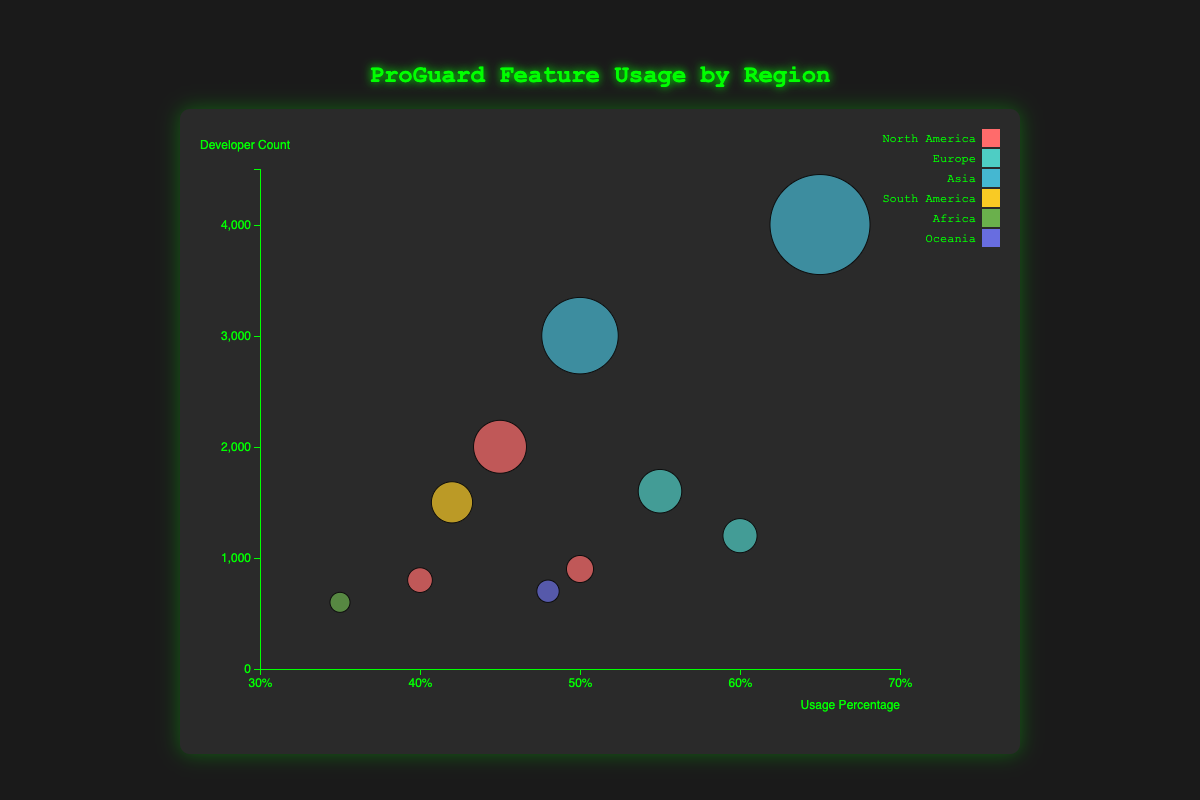What is the title of the chart? The title is displayed at the top of the chart in the larger font size: "ProGuard Feature Usage by Region".
Answer: ProGuard Feature Usage by Region What is the x-axis label? The x-axis label is found at the bottom of the x-axis, indicating the horizontal measurement: "Usage Percentage".
Answer: Usage Percentage What is the largest bubble representing and which data point does it correspond to? The largest bubble represents the highest developer count. It corresponds to China, with 4000 developers and 65% usage percentage for the "Obfuscation" feature.
Answer: China Which region has the highest usage percentage for the "Shrinking" feature, and what is the value? In the figure, bubbles are color-coded by region. The bubble for "Shrinking" with the highest usage percentage is found in the United Kingdom, in the Europe region, with a 60% usage percentage.
Answer: United Kingdom, 60% How many developers from North America use ProGuard's Optimization feature? There are bubbles for North America labeled "USA" and "Mexico" with the "Optimization" feature. Adding the developer counts (2000 for USA and 900 for Mexico) totals 2900 developers.
Answer: 2900 Which country has a higher usage percentage for ProGuard's Optimization feature, India or Nigeria? By comparing the usage percentages for India and Nigeria on the x-axis, India has 50% while Nigeria has 35%. India has a higher usage percentage.
Answer: India What is the difference in developer count between the country with the maximum and minimum usage percentages for the "Obfuscation" feature? The maximum usage percentage for "Obfuscation" is in China (65%) and the minimum is in Australia (48%). The difference in developer count is 4000 - 700 = 3300.
Answer: 3300 Which regions have countries with an average usage percentage above 50%? Calculate the average usage percentage for each region: 
- North America (USA: 45%, Canada: 40%, Mexico: 50%) = (45+40+50)/3 = 45%
- Europe (Germany: 55%, UK: 60%) = (55+60)/2 = 57.5%
- Asia (India: 50%, China: 65%) = (50+65)/2 = 57.5%
- South America (Brazil: 42%) = 42%
- Africa (Nigeria: 35%) = 35%
- Oceania (Australia: 48%) = 48%
Regions with an average above 50% are Europe and Asia.
Answer: Europe and Asia How many bubbles are on the chart? Count the total number of bubbles representing individual data points. There are 10 bubbles.
Answer: 10 Which feature has the highest usage percentage in Asia, and what is the percentage? By analyzing bubbles within the Asia region, "Obfuscation" (China) has the highest usage percentage at 65%.
Answer: Obfuscation, 65% 